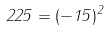<formula> <loc_0><loc_0><loc_500><loc_500>2 2 5 = ( - 1 5 ) ^ { 2 }</formula> 